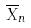Convert formula to latex. <formula><loc_0><loc_0><loc_500><loc_500>\overline { X } _ { n }</formula> 